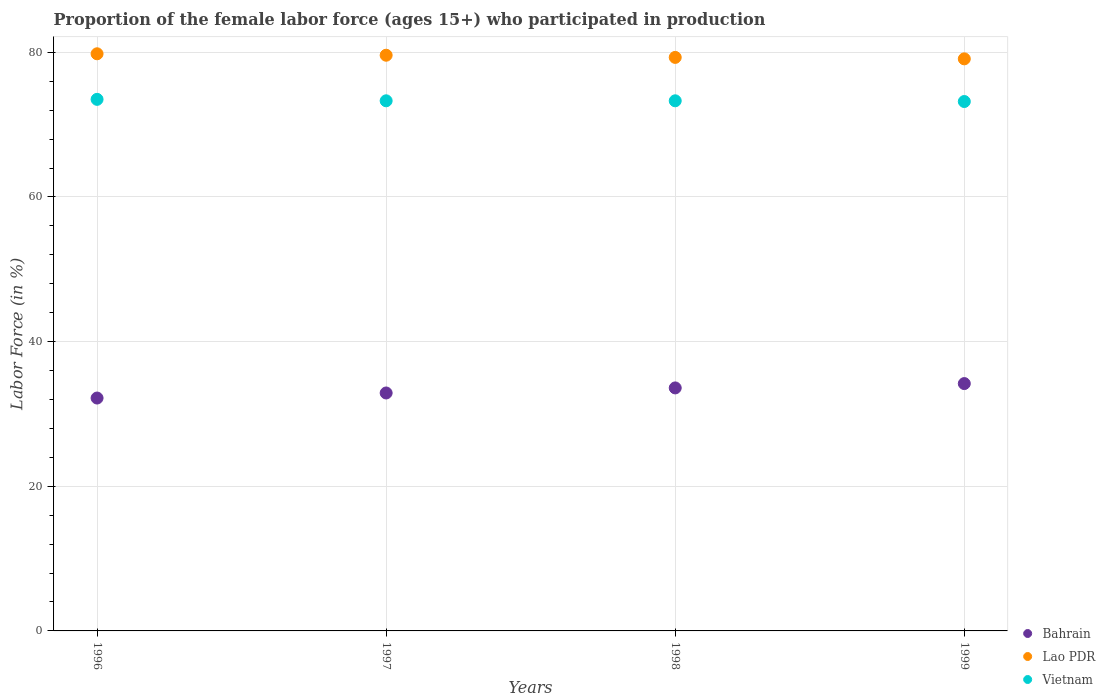How many different coloured dotlines are there?
Your answer should be compact. 3. What is the proportion of the female labor force who participated in production in Lao PDR in 1998?
Your answer should be compact. 79.3. Across all years, what is the maximum proportion of the female labor force who participated in production in Vietnam?
Keep it short and to the point. 73.5. Across all years, what is the minimum proportion of the female labor force who participated in production in Lao PDR?
Offer a terse response. 79.1. What is the total proportion of the female labor force who participated in production in Lao PDR in the graph?
Keep it short and to the point. 317.8. What is the difference between the proportion of the female labor force who participated in production in Bahrain in 1996 and that in 1999?
Your response must be concise. -2. What is the difference between the proportion of the female labor force who participated in production in Lao PDR in 1998 and the proportion of the female labor force who participated in production in Bahrain in 1997?
Your answer should be very brief. 46.4. What is the average proportion of the female labor force who participated in production in Lao PDR per year?
Provide a succinct answer. 79.45. In the year 1998, what is the difference between the proportion of the female labor force who participated in production in Bahrain and proportion of the female labor force who participated in production in Vietnam?
Your answer should be very brief. -39.7. What is the ratio of the proportion of the female labor force who participated in production in Bahrain in 1996 to that in 1998?
Make the answer very short. 0.96. Is the proportion of the female labor force who participated in production in Lao PDR in 1998 less than that in 1999?
Your answer should be compact. No. Is the difference between the proportion of the female labor force who participated in production in Bahrain in 1997 and 1998 greater than the difference between the proportion of the female labor force who participated in production in Vietnam in 1997 and 1998?
Your answer should be very brief. No. What is the difference between the highest and the second highest proportion of the female labor force who participated in production in Vietnam?
Provide a short and direct response. 0.2. Is the sum of the proportion of the female labor force who participated in production in Lao PDR in 1996 and 1998 greater than the maximum proportion of the female labor force who participated in production in Bahrain across all years?
Your response must be concise. Yes. Does the proportion of the female labor force who participated in production in Vietnam monotonically increase over the years?
Your response must be concise. No. How many dotlines are there?
Provide a short and direct response. 3. Are the values on the major ticks of Y-axis written in scientific E-notation?
Your answer should be very brief. No. Does the graph contain grids?
Give a very brief answer. Yes. How many legend labels are there?
Your answer should be very brief. 3. How are the legend labels stacked?
Your response must be concise. Vertical. What is the title of the graph?
Provide a short and direct response. Proportion of the female labor force (ages 15+) who participated in production. What is the Labor Force (in %) in Bahrain in 1996?
Ensure brevity in your answer.  32.2. What is the Labor Force (in %) of Lao PDR in 1996?
Ensure brevity in your answer.  79.8. What is the Labor Force (in %) of Vietnam in 1996?
Your answer should be very brief. 73.5. What is the Labor Force (in %) of Bahrain in 1997?
Offer a very short reply. 32.9. What is the Labor Force (in %) of Lao PDR in 1997?
Give a very brief answer. 79.6. What is the Labor Force (in %) of Vietnam in 1997?
Your response must be concise. 73.3. What is the Labor Force (in %) of Bahrain in 1998?
Keep it short and to the point. 33.6. What is the Labor Force (in %) of Lao PDR in 1998?
Your answer should be compact. 79.3. What is the Labor Force (in %) of Vietnam in 1998?
Make the answer very short. 73.3. What is the Labor Force (in %) of Bahrain in 1999?
Ensure brevity in your answer.  34.2. What is the Labor Force (in %) of Lao PDR in 1999?
Make the answer very short. 79.1. What is the Labor Force (in %) of Vietnam in 1999?
Ensure brevity in your answer.  73.2. Across all years, what is the maximum Labor Force (in %) in Bahrain?
Offer a very short reply. 34.2. Across all years, what is the maximum Labor Force (in %) in Lao PDR?
Keep it short and to the point. 79.8. Across all years, what is the maximum Labor Force (in %) in Vietnam?
Ensure brevity in your answer.  73.5. Across all years, what is the minimum Labor Force (in %) in Bahrain?
Keep it short and to the point. 32.2. Across all years, what is the minimum Labor Force (in %) of Lao PDR?
Keep it short and to the point. 79.1. Across all years, what is the minimum Labor Force (in %) of Vietnam?
Your answer should be compact. 73.2. What is the total Labor Force (in %) in Bahrain in the graph?
Ensure brevity in your answer.  132.9. What is the total Labor Force (in %) in Lao PDR in the graph?
Give a very brief answer. 317.8. What is the total Labor Force (in %) of Vietnam in the graph?
Provide a succinct answer. 293.3. What is the difference between the Labor Force (in %) in Vietnam in 1996 and that in 1997?
Offer a terse response. 0.2. What is the difference between the Labor Force (in %) of Bahrain in 1996 and that in 1998?
Provide a succinct answer. -1.4. What is the difference between the Labor Force (in %) of Bahrain in 1996 and that in 1999?
Give a very brief answer. -2. What is the difference between the Labor Force (in %) of Lao PDR in 1996 and that in 1999?
Make the answer very short. 0.7. What is the difference between the Labor Force (in %) in Vietnam in 1997 and that in 1998?
Offer a terse response. 0. What is the difference between the Labor Force (in %) of Bahrain in 1997 and that in 1999?
Offer a very short reply. -1.3. What is the difference between the Labor Force (in %) in Vietnam in 1997 and that in 1999?
Provide a succinct answer. 0.1. What is the difference between the Labor Force (in %) in Lao PDR in 1998 and that in 1999?
Your answer should be very brief. 0.2. What is the difference between the Labor Force (in %) of Bahrain in 1996 and the Labor Force (in %) of Lao PDR in 1997?
Give a very brief answer. -47.4. What is the difference between the Labor Force (in %) in Bahrain in 1996 and the Labor Force (in %) in Vietnam in 1997?
Give a very brief answer. -41.1. What is the difference between the Labor Force (in %) in Lao PDR in 1996 and the Labor Force (in %) in Vietnam in 1997?
Keep it short and to the point. 6.5. What is the difference between the Labor Force (in %) of Bahrain in 1996 and the Labor Force (in %) of Lao PDR in 1998?
Offer a very short reply. -47.1. What is the difference between the Labor Force (in %) in Bahrain in 1996 and the Labor Force (in %) in Vietnam in 1998?
Give a very brief answer. -41.1. What is the difference between the Labor Force (in %) of Bahrain in 1996 and the Labor Force (in %) of Lao PDR in 1999?
Offer a very short reply. -46.9. What is the difference between the Labor Force (in %) of Bahrain in 1996 and the Labor Force (in %) of Vietnam in 1999?
Your answer should be compact. -41. What is the difference between the Labor Force (in %) of Bahrain in 1997 and the Labor Force (in %) of Lao PDR in 1998?
Offer a very short reply. -46.4. What is the difference between the Labor Force (in %) of Bahrain in 1997 and the Labor Force (in %) of Vietnam in 1998?
Give a very brief answer. -40.4. What is the difference between the Labor Force (in %) of Bahrain in 1997 and the Labor Force (in %) of Lao PDR in 1999?
Offer a very short reply. -46.2. What is the difference between the Labor Force (in %) of Bahrain in 1997 and the Labor Force (in %) of Vietnam in 1999?
Keep it short and to the point. -40.3. What is the difference between the Labor Force (in %) of Lao PDR in 1997 and the Labor Force (in %) of Vietnam in 1999?
Give a very brief answer. 6.4. What is the difference between the Labor Force (in %) in Bahrain in 1998 and the Labor Force (in %) in Lao PDR in 1999?
Provide a short and direct response. -45.5. What is the difference between the Labor Force (in %) in Bahrain in 1998 and the Labor Force (in %) in Vietnam in 1999?
Provide a succinct answer. -39.6. What is the difference between the Labor Force (in %) of Lao PDR in 1998 and the Labor Force (in %) of Vietnam in 1999?
Ensure brevity in your answer.  6.1. What is the average Labor Force (in %) of Bahrain per year?
Keep it short and to the point. 33.23. What is the average Labor Force (in %) of Lao PDR per year?
Offer a terse response. 79.45. What is the average Labor Force (in %) of Vietnam per year?
Your answer should be compact. 73.33. In the year 1996, what is the difference between the Labor Force (in %) in Bahrain and Labor Force (in %) in Lao PDR?
Your answer should be very brief. -47.6. In the year 1996, what is the difference between the Labor Force (in %) of Bahrain and Labor Force (in %) of Vietnam?
Provide a succinct answer. -41.3. In the year 1996, what is the difference between the Labor Force (in %) in Lao PDR and Labor Force (in %) in Vietnam?
Provide a succinct answer. 6.3. In the year 1997, what is the difference between the Labor Force (in %) of Bahrain and Labor Force (in %) of Lao PDR?
Your answer should be compact. -46.7. In the year 1997, what is the difference between the Labor Force (in %) in Bahrain and Labor Force (in %) in Vietnam?
Your response must be concise. -40.4. In the year 1998, what is the difference between the Labor Force (in %) of Bahrain and Labor Force (in %) of Lao PDR?
Provide a succinct answer. -45.7. In the year 1998, what is the difference between the Labor Force (in %) in Bahrain and Labor Force (in %) in Vietnam?
Make the answer very short. -39.7. In the year 1999, what is the difference between the Labor Force (in %) in Bahrain and Labor Force (in %) in Lao PDR?
Make the answer very short. -44.9. In the year 1999, what is the difference between the Labor Force (in %) in Bahrain and Labor Force (in %) in Vietnam?
Make the answer very short. -39. What is the ratio of the Labor Force (in %) in Bahrain in 1996 to that in 1997?
Offer a terse response. 0.98. What is the ratio of the Labor Force (in %) of Lao PDR in 1996 to that in 1997?
Give a very brief answer. 1. What is the ratio of the Labor Force (in %) in Vietnam in 1996 to that in 1997?
Give a very brief answer. 1. What is the ratio of the Labor Force (in %) of Vietnam in 1996 to that in 1998?
Provide a succinct answer. 1. What is the ratio of the Labor Force (in %) in Bahrain in 1996 to that in 1999?
Keep it short and to the point. 0.94. What is the ratio of the Labor Force (in %) in Lao PDR in 1996 to that in 1999?
Keep it short and to the point. 1.01. What is the ratio of the Labor Force (in %) in Bahrain in 1997 to that in 1998?
Ensure brevity in your answer.  0.98. What is the ratio of the Labor Force (in %) in Lao PDR in 1997 to that in 1998?
Provide a short and direct response. 1. What is the ratio of the Labor Force (in %) in Vietnam in 1997 to that in 1998?
Provide a short and direct response. 1. What is the ratio of the Labor Force (in %) of Lao PDR in 1997 to that in 1999?
Your answer should be compact. 1.01. What is the ratio of the Labor Force (in %) of Vietnam in 1997 to that in 1999?
Ensure brevity in your answer.  1. What is the ratio of the Labor Force (in %) of Bahrain in 1998 to that in 1999?
Provide a succinct answer. 0.98. What is the ratio of the Labor Force (in %) in Vietnam in 1998 to that in 1999?
Provide a short and direct response. 1. What is the difference between the highest and the second highest Labor Force (in %) in Lao PDR?
Your answer should be very brief. 0.2. What is the difference between the highest and the lowest Labor Force (in %) in Bahrain?
Keep it short and to the point. 2. What is the difference between the highest and the lowest Labor Force (in %) of Lao PDR?
Ensure brevity in your answer.  0.7. 